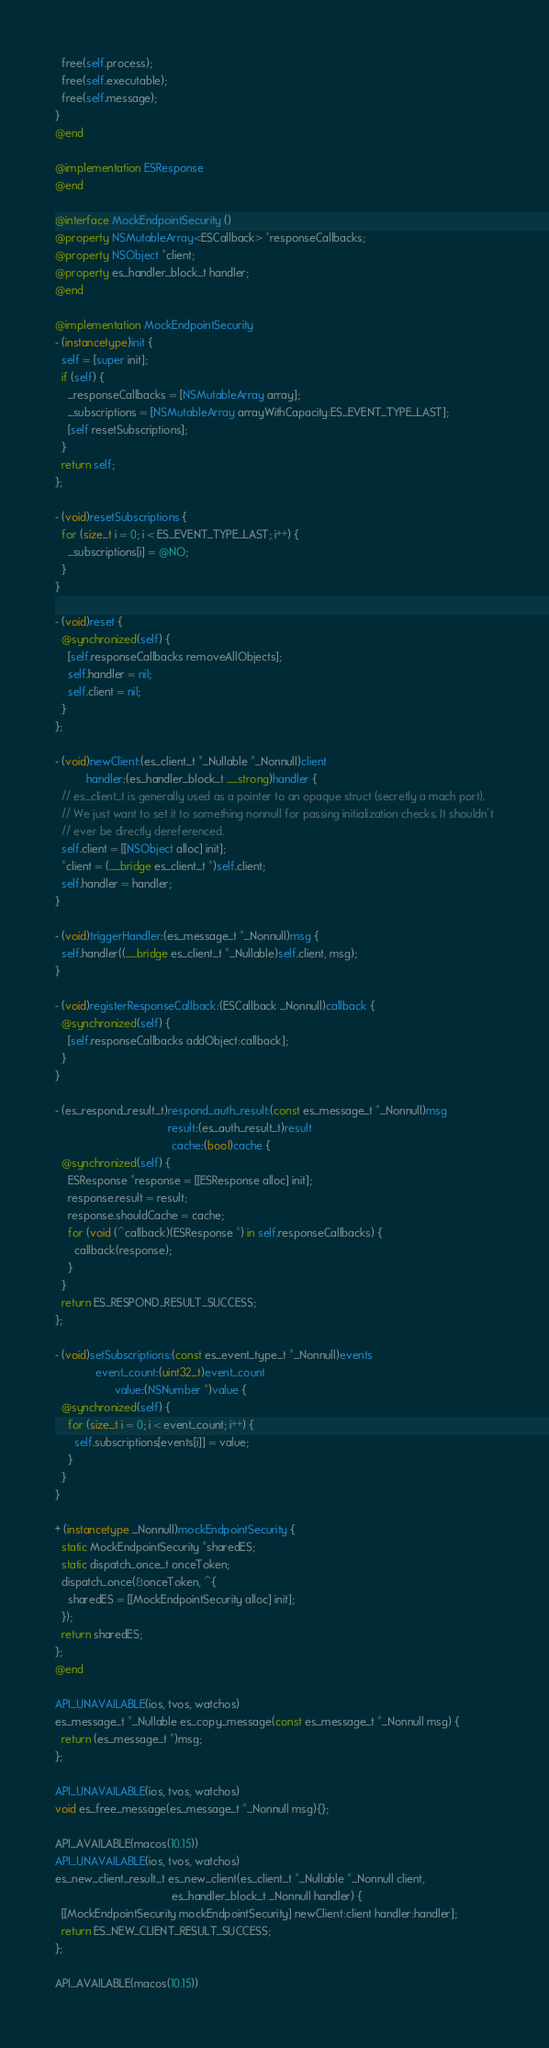<code> <loc_0><loc_0><loc_500><loc_500><_ObjectiveC_>  free(self.process);
  free(self.executable);
  free(self.message);
}
@end

@implementation ESResponse
@end

@interface MockEndpointSecurity ()
@property NSMutableArray<ESCallback> *responseCallbacks;
@property NSObject *client;
@property es_handler_block_t handler;
@end

@implementation MockEndpointSecurity
- (instancetype)init {
  self = [super init];
  if (self) {
    _responseCallbacks = [NSMutableArray array];
    _subscriptions = [NSMutableArray arrayWithCapacity:ES_EVENT_TYPE_LAST];
    [self resetSubscriptions];
  }
  return self;
};

- (void)resetSubscriptions {
  for (size_t i = 0; i < ES_EVENT_TYPE_LAST; i++) {
    _subscriptions[i] = @NO;
  }
}

- (void)reset {
  @synchronized(self) {
    [self.responseCallbacks removeAllObjects];
    self.handler = nil;
    self.client = nil;
  }
};

- (void)newClient:(es_client_t *_Nullable *_Nonnull)client
          handler:(es_handler_block_t __strong)handler {
  // es_client_t is generally used as a pointer to an opaque struct (secretly a mach port).
  // We just want to set it to something nonnull for passing initialization checks. It shouldn't
  // ever be directly dereferenced.
  self.client = [[NSObject alloc] init];
  *client = (__bridge es_client_t *)self.client;
  self.handler = handler;
}

- (void)triggerHandler:(es_message_t *_Nonnull)msg {
  self.handler((__bridge es_client_t *_Nullable)self.client, msg);
}

- (void)registerResponseCallback:(ESCallback _Nonnull)callback {
  @synchronized(self) {
    [self.responseCallbacks addObject:callback];
  }
}

- (es_respond_result_t)respond_auth_result:(const es_message_t *_Nonnull)msg
                                    result:(es_auth_result_t)result
                                     cache:(bool)cache {
  @synchronized(self) {
    ESResponse *response = [[ESResponse alloc] init];
    response.result = result;
    response.shouldCache = cache;
    for (void (^callback)(ESResponse *) in self.responseCallbacks) {
      callback(response);
    }
  }
  return ES_RESPOND_RESULT_SUCCESS;
};

- (void)setSubscriptions:(const es_event_type_t *_Nonnull)events
             event_count:(uint32_t)event_count
                   value:(NSNumber *)value {
  @synchronized(self) {
    for (size_t i = 0; i < event_count; i++) {
      self.subscriptions[events[i]] = value;
    }
  }
}

+ (instancetype _Nonnull)mockEndpointSecurity {
  static MockEndpointSecurity *sharedES;
  static dispatch_once_t onceToken;
  dispatch_once(&onceToken, ^{
    sharedES = [[MockEndpointSecurity alloc] init];
  });
  return sharedES;
};
@end

API_UNAVAILABLE(ios, tvos, watchos)
es_message_t *_Nullable es_copy_message(const es_message_t *_Nonnull msg) {
  return (es_message_t *)msg;
};

API_UNAVAILABLE(ios, tvos, watchos)
void es_free_message(es_message_t *_Nonnull msg){};

API_AVAILABLE(macos(10.15))
API_UNAVAILABLE(ios, tvos, watchos)
es_new_client_result_t es_new_client(es_client_t *_Nullable *_Nonnull client,
                                     es_handler_block_t _Nonnull handler) {
  [[MockEndpointSecurity mockEndpointSecurity] newClient:client handler:handler];
  return ES_NEW_CLIENT_RESULT_SUCCESS;
};

API_AVAILABLE(macos(10.15))</code> 